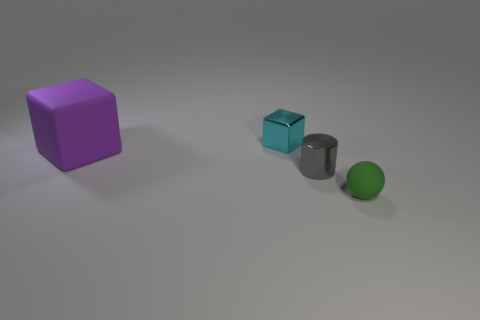Add 2 green spheres. How many objects exist? 6 Subtract all spheres. How many objects are left? 3 Subtract all big cyan objects. Subtract all purple cubes. How many objects are left? 3 Add 3 metallic cylinders. How many metallic cylinders are left? 4 Add 4 cyan objects. How many cyan objects exist? 5 Subtract 0 blue cubes. How many objects are left? 4 